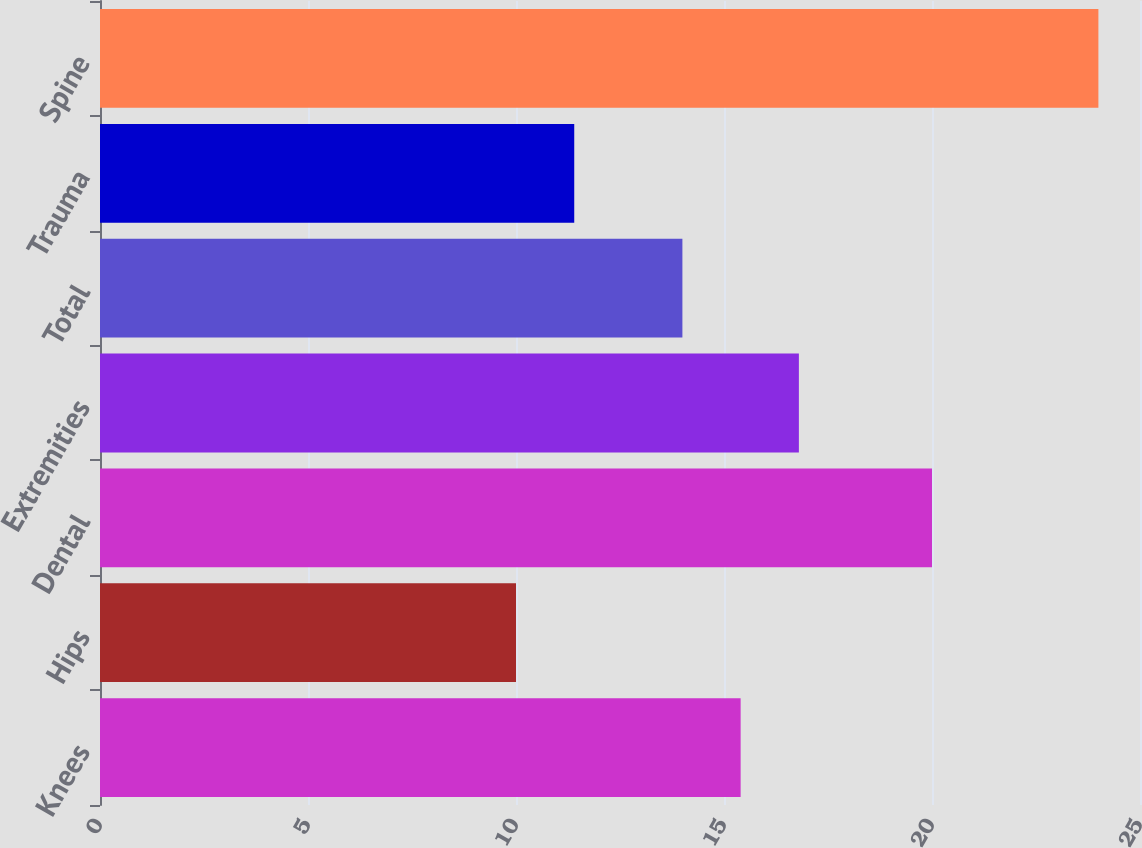<chart> <loc_0><loc_0><loc_500><loc_500><bar_chart><fcel>Knees<fcel>Hips<fcel>Dental<fcel>Extremities<fcel>Total<fcel>Trauma<fcel>Spine<nl><fcel>15.4<fcel>10<fcel>20<fcel>16.8<fcel>14<fcel>11.4<fcel>24<nl></chart> 